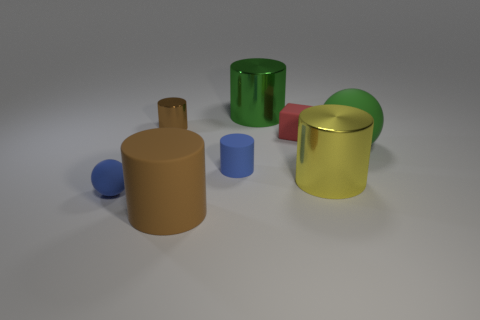What does the arrangement of these objects suggest about their relationship? The arrangement of the objects may be purely aesthetic for a neutral composition, or it could be a display designed to compare sizes, shapes, and colors. They are placed with enough space between them to showcase their individual properties. 